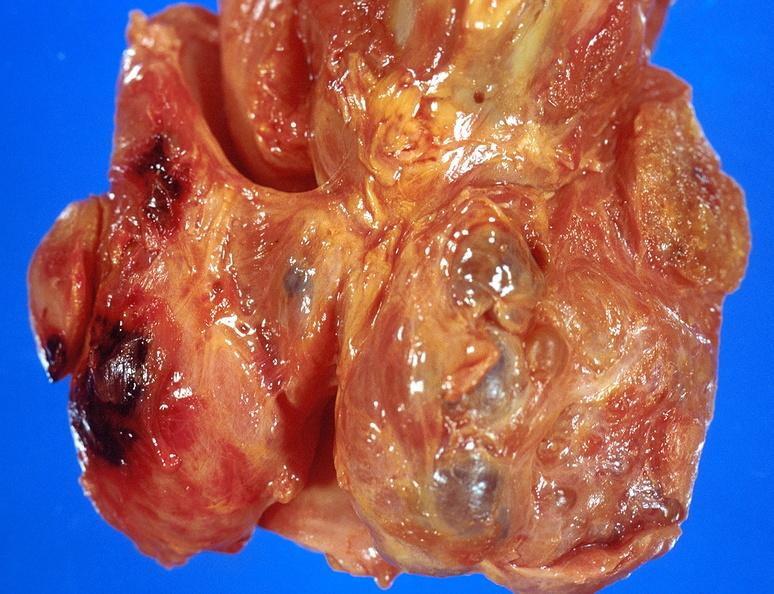where does this belong to?
Answer the question using a single word or phrase. Endocrine system 